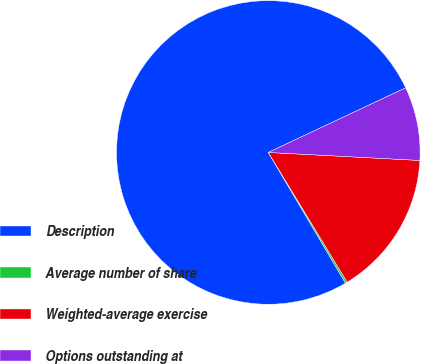<chart> <loc_0><loc_0><loc_500><loc_500><pie_chart><fcel>Description<fcel>Average number of share<fcel>Weighted-average exercise<fcel>Options outstanding at<nl><fcel>76.49%<fcel>0.21%<fcel>15.46%<fcel>7.84%<nl></chart> 